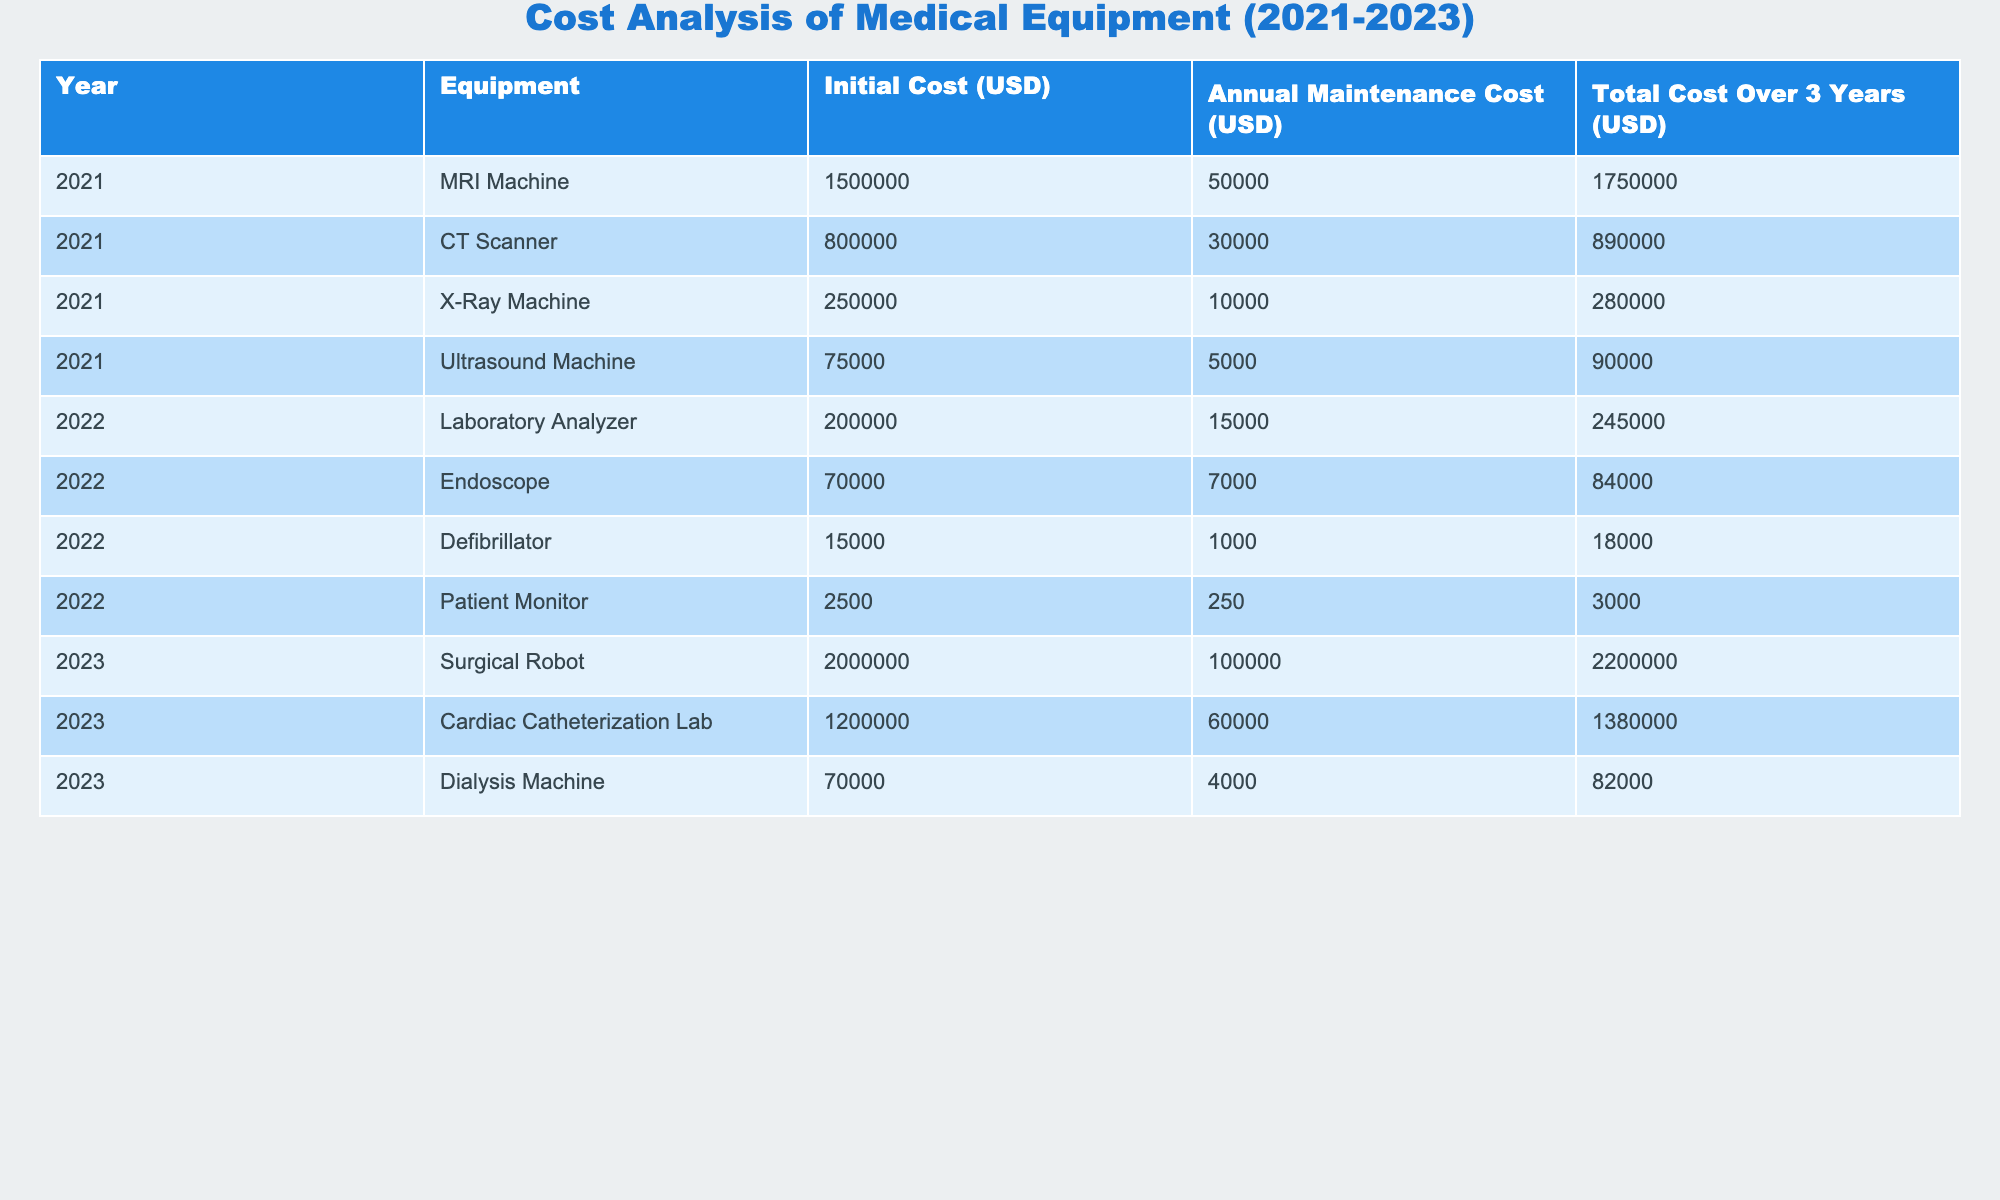What is the total cost of the MRI Machine over 3 years? The total cost for the MRI Machine is listed directly in the table under "Total Cost Over 3 Years," which is 1,750,000 USD.
Answer: 1,750,000 USD Which equipment has the highest initial cost and what is that cost? By reviewing the "Initial Cost (USD)" column, the Surgical Robot has the highest initial cost of 2,000,000 USD.
Answer: 2,000,000 USD What is the total annual maintenance cost for all the equipment listed in 2022? To find this, sum the annual maintenance costs for each piece of equipment in 2022: 15,000 + 7,000 + 1,000 + 250 = 23,250 USD.
Answer: 23,250 USD Is the total cost for the CT Scanner more than the total cost for the X-Ray Machine? The total cost for the CT Scanner is 890,000 USD and for the X-Ray Machine is 280,000 USD. Since 890,000 is greater than 280,000, the statement is true.
Answer: Yes What is the average total cost of equipment across all the years from 2021 to 2023? The total costs are 1,750,000 (MRI) + 890,000 (CT) + 280,000 (X-Ray) + 90,000 (Ultrasound) + 245,000 (Lab) + 84,000 (Endoscope) + 18,000 (Defibrillator) + 3,000 (Patient Monitor) + 2,200,000 (Surgical Robot) + 1,380,000 (Cardiac Lab) + 82,000 (Dialysis) = 6,200,000 USD. Divided by the number of entries (11): 6,200,000 / 11 = 563,636.36 (approximately).
Answer: 563,636.36 USD Which year had the most expensive individual piece of equipment and what was its total cost? The Surgical Robot from 2023 costs a total of 2,200,000 USD, which is the highest individual cost listed in the table.
Answer: 2,200,000 USD What was the total cost difference between the Surgical Robot and the Defibrillator? The total cost for the Surgical Robot is 2,200,000 USD and for the Defibrillator, it is 18,000 USD. The difference is 2,200,000 - 18,000 = 2,182,000 USD.
Answer: 2,182,000 USD 